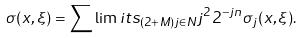<formula> <loc_0><loc_0><loc_500><loc_500>\sigma ( x , \xi ) = \sum \lim i t s _ { ( 2 + M ) j \in N } j ^ { 2 } 2 ^ { - j n } \sigma _ { j } ( x , \xi ) .</formula> 